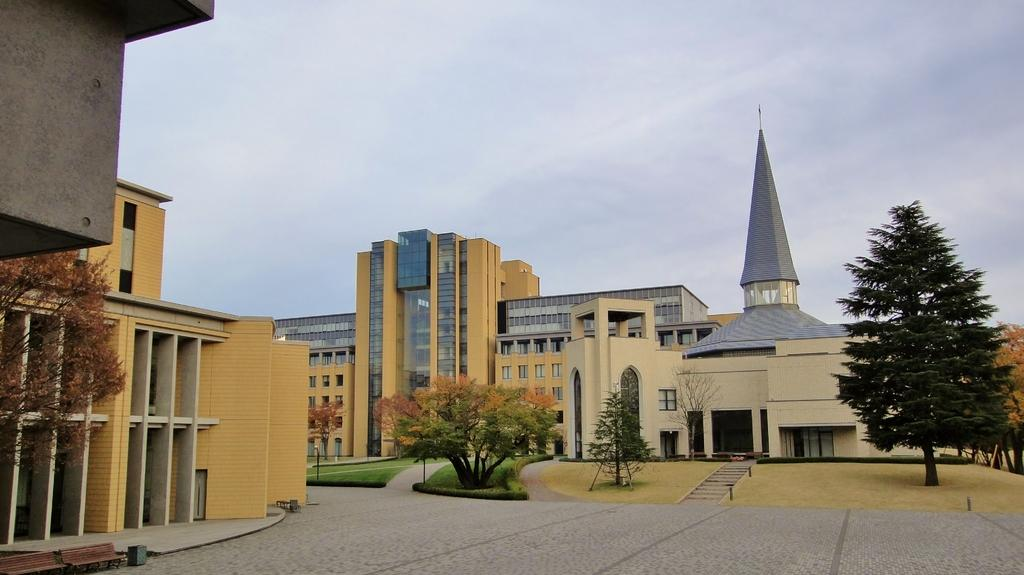What can be seen in the background of the image? There are buildings and many trees in the background of the image. What is located in the foreground of the image? There is a garden in the foreground of the image. What is visible in the sky in the image? The sky is visible in the image, and clouds are present. How long does it take for the clouds to teach the trees in the image? There is no teaching activity involving clouds and trees in the image. The clouds are simply present in the sky, and the trees are part of the background. 